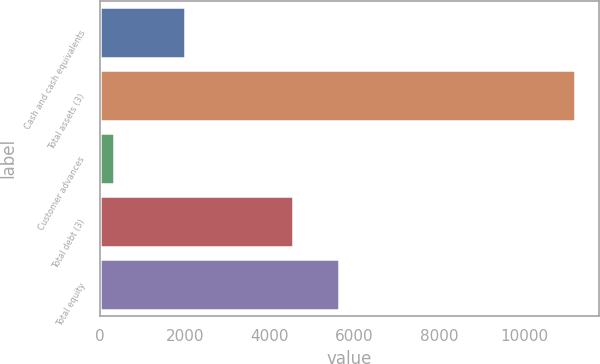<chart> <loc_0><loc_0><loc_500><loc_500><bar_chart><fcel>Cash and cash equivalents<fcel>Total assets (3)<fcel>Customer advances<fcel>Total debt (3)<fcel>Total equity<nl><fcel>1997<fcel>11200<fcel>325<fcel>4538<fcel>5625.5<nl></chart> 